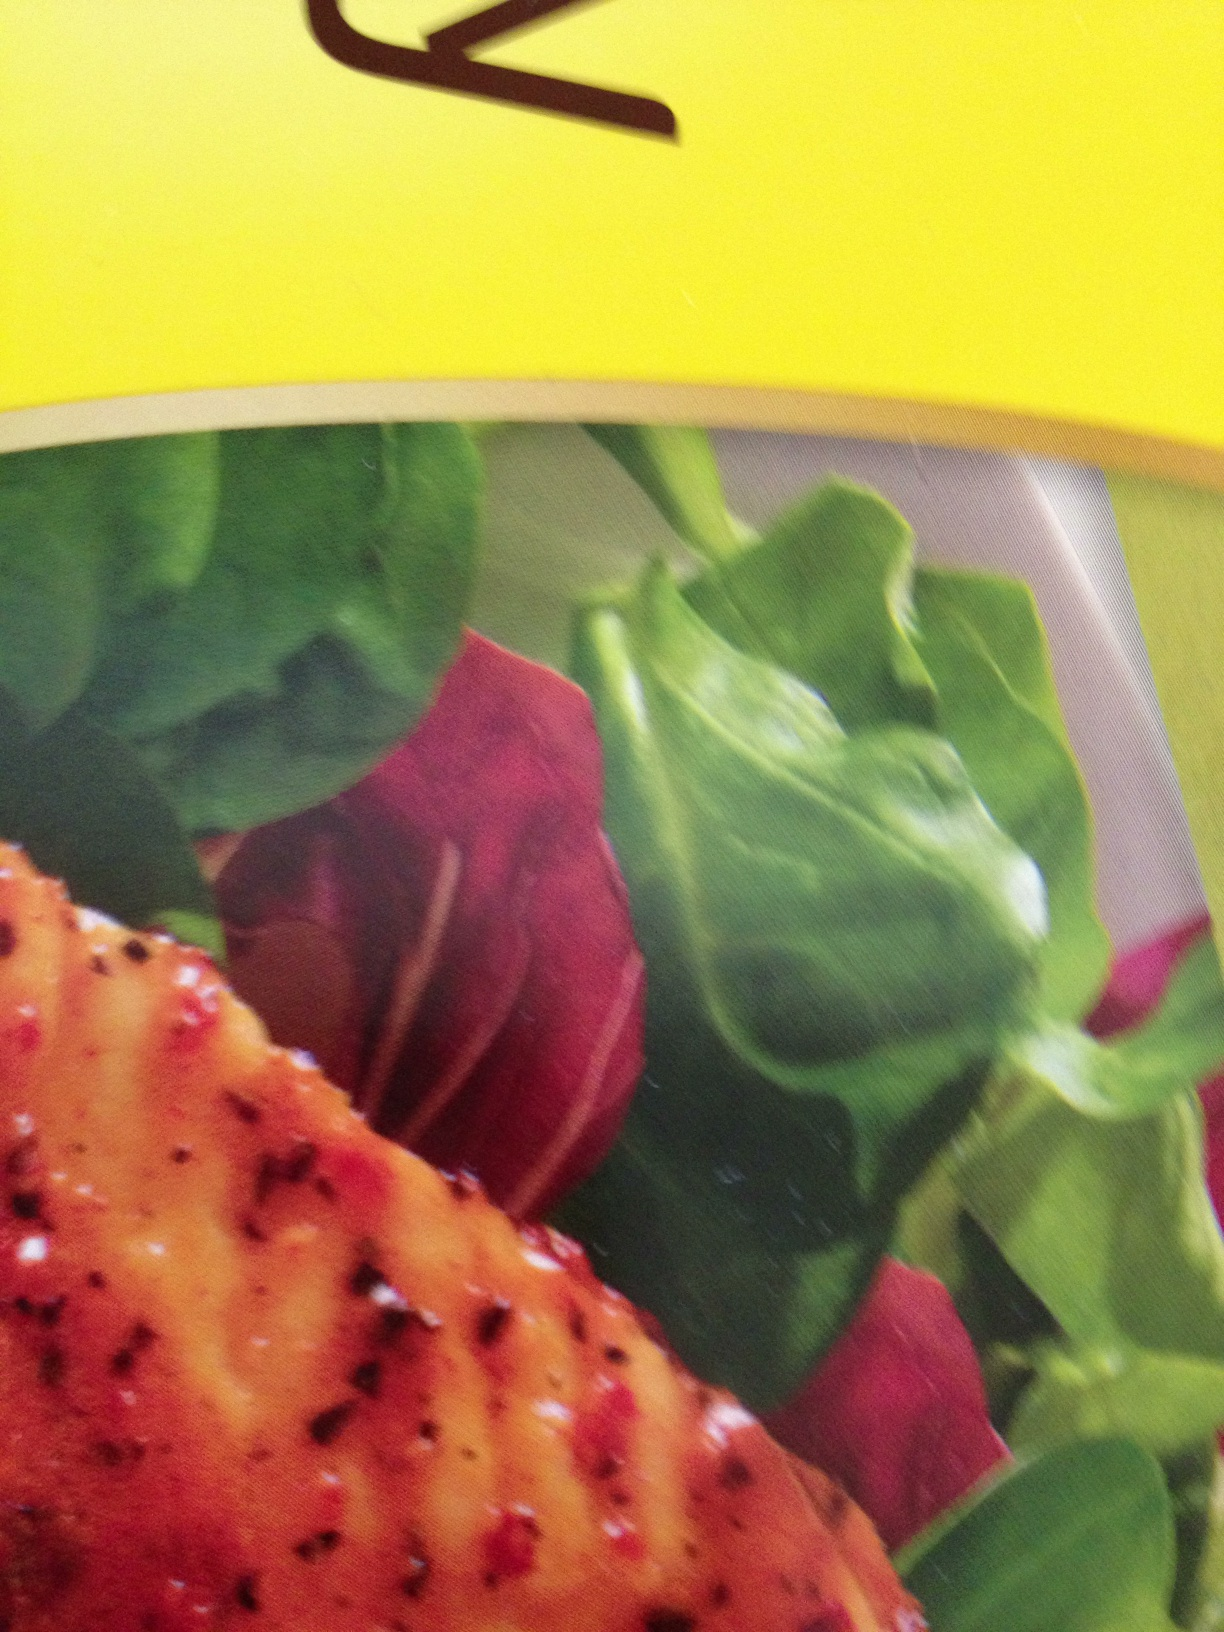Can you give a detailed recipe for recreating this dish at home? Certainly! Here’s a detailed recipe to recreate this dish at home:

Ingredients:
- 2 chicken breasts (or fish fillets)
- 2 cups fresh salad greens (such as spinach, arugula, and lettuce)
- 1 beet, thinly sliced
- Olive oil
- Salt and pepper to taste
- 1 tablespoon paprika
- 1 teaspoon garlic powder
- 1 teaspoon onion powder
- 1 teaspoon dried oregano
- Juice of 1 lemon
- Balsharegpt4v/samic vinegar for dressing

Instructions:
1. In a small bowl, mix paprika, garlic powder, onion powder, oregano, salt, and pepper. Rub this spice mixture all over the chicken breasts or fish fillets.
2. Heat a grill pan or skillet over medium heat and add a drizzle of olive oil.
3. Place the seasoned chicken or fish on the grill and cook for 6-7 minutes on each side, or until fully cooked and golden brown.
4. While the protein is cooking, prepare the salad. In a large bowl, combine the fresh greens and beet slices.
5. In a small bowl, whisk together olive oil, lemon juice, balsharegpt4v/samic vinegar, salt, and pepper to make the dressing.
6. Once the chicken or fish is cooked, let it rest for a few minutes before slicing it into strips.
7. Toss the salad greens and beets with the dressing, ensuring all ingredients are well-coated.
8. Serve the grilled chicken or fish over the salad. Enjoy your meal! 